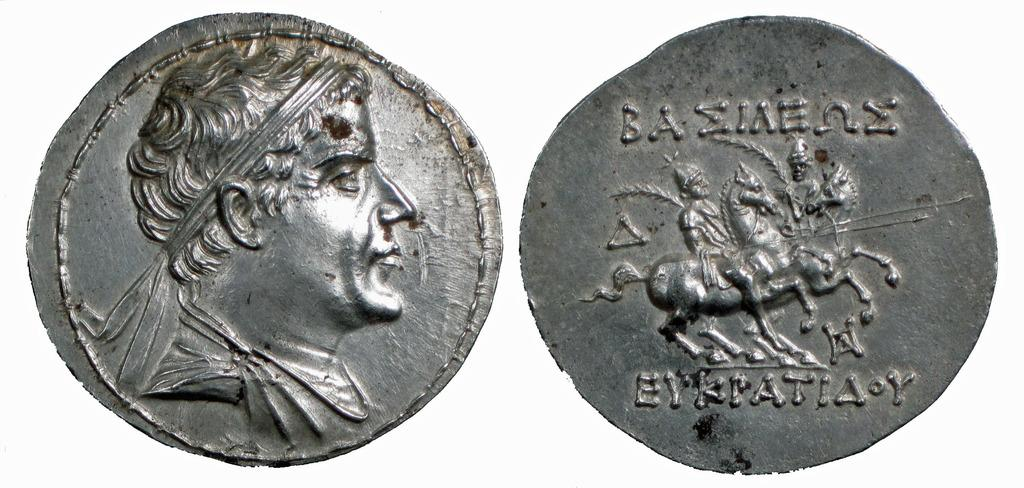<image>
Provide a brief description of the given image. Two silver coins with a head on left coin, and a word on the right coin saying: Baziaeue. 